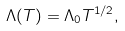Convert formula to latex. <formula><loc_0><loc_0><loc_500><loc_500>\Lambda ( T ) = \Lambda _ { 0 } T ^ { 1 / 2 } ,</formula> 